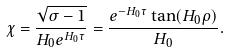<formula> <loc_0><loc_0><loc_500><loc_500>\chi = \frac { \sqrt { \sigma - 1 } } { H _ { 0 } e ^ { H _ { 0 } \tau } } = \frac { e ^ { - H _ { 0 } \tau } \tan ( H _ { 0 } \rho ) } { H _ { 0 } } .</formula> 